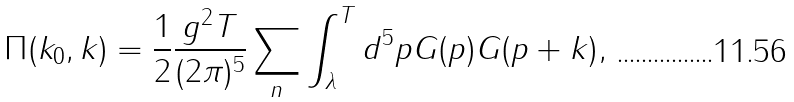<formula> <loc_0><loc_0><loc_500><loc_500>\Pi ( k _ { 0 } , k ) = \frac { 1 } { 2 } \frac { g ^ { 2 } T } { ( 2 \pi ) ^ { 5 } } \sum _ { n } \int _ { \lambda } ^ { T } d ^ { 5 } p G ( p ) G ( p + k ) ,</formula> 